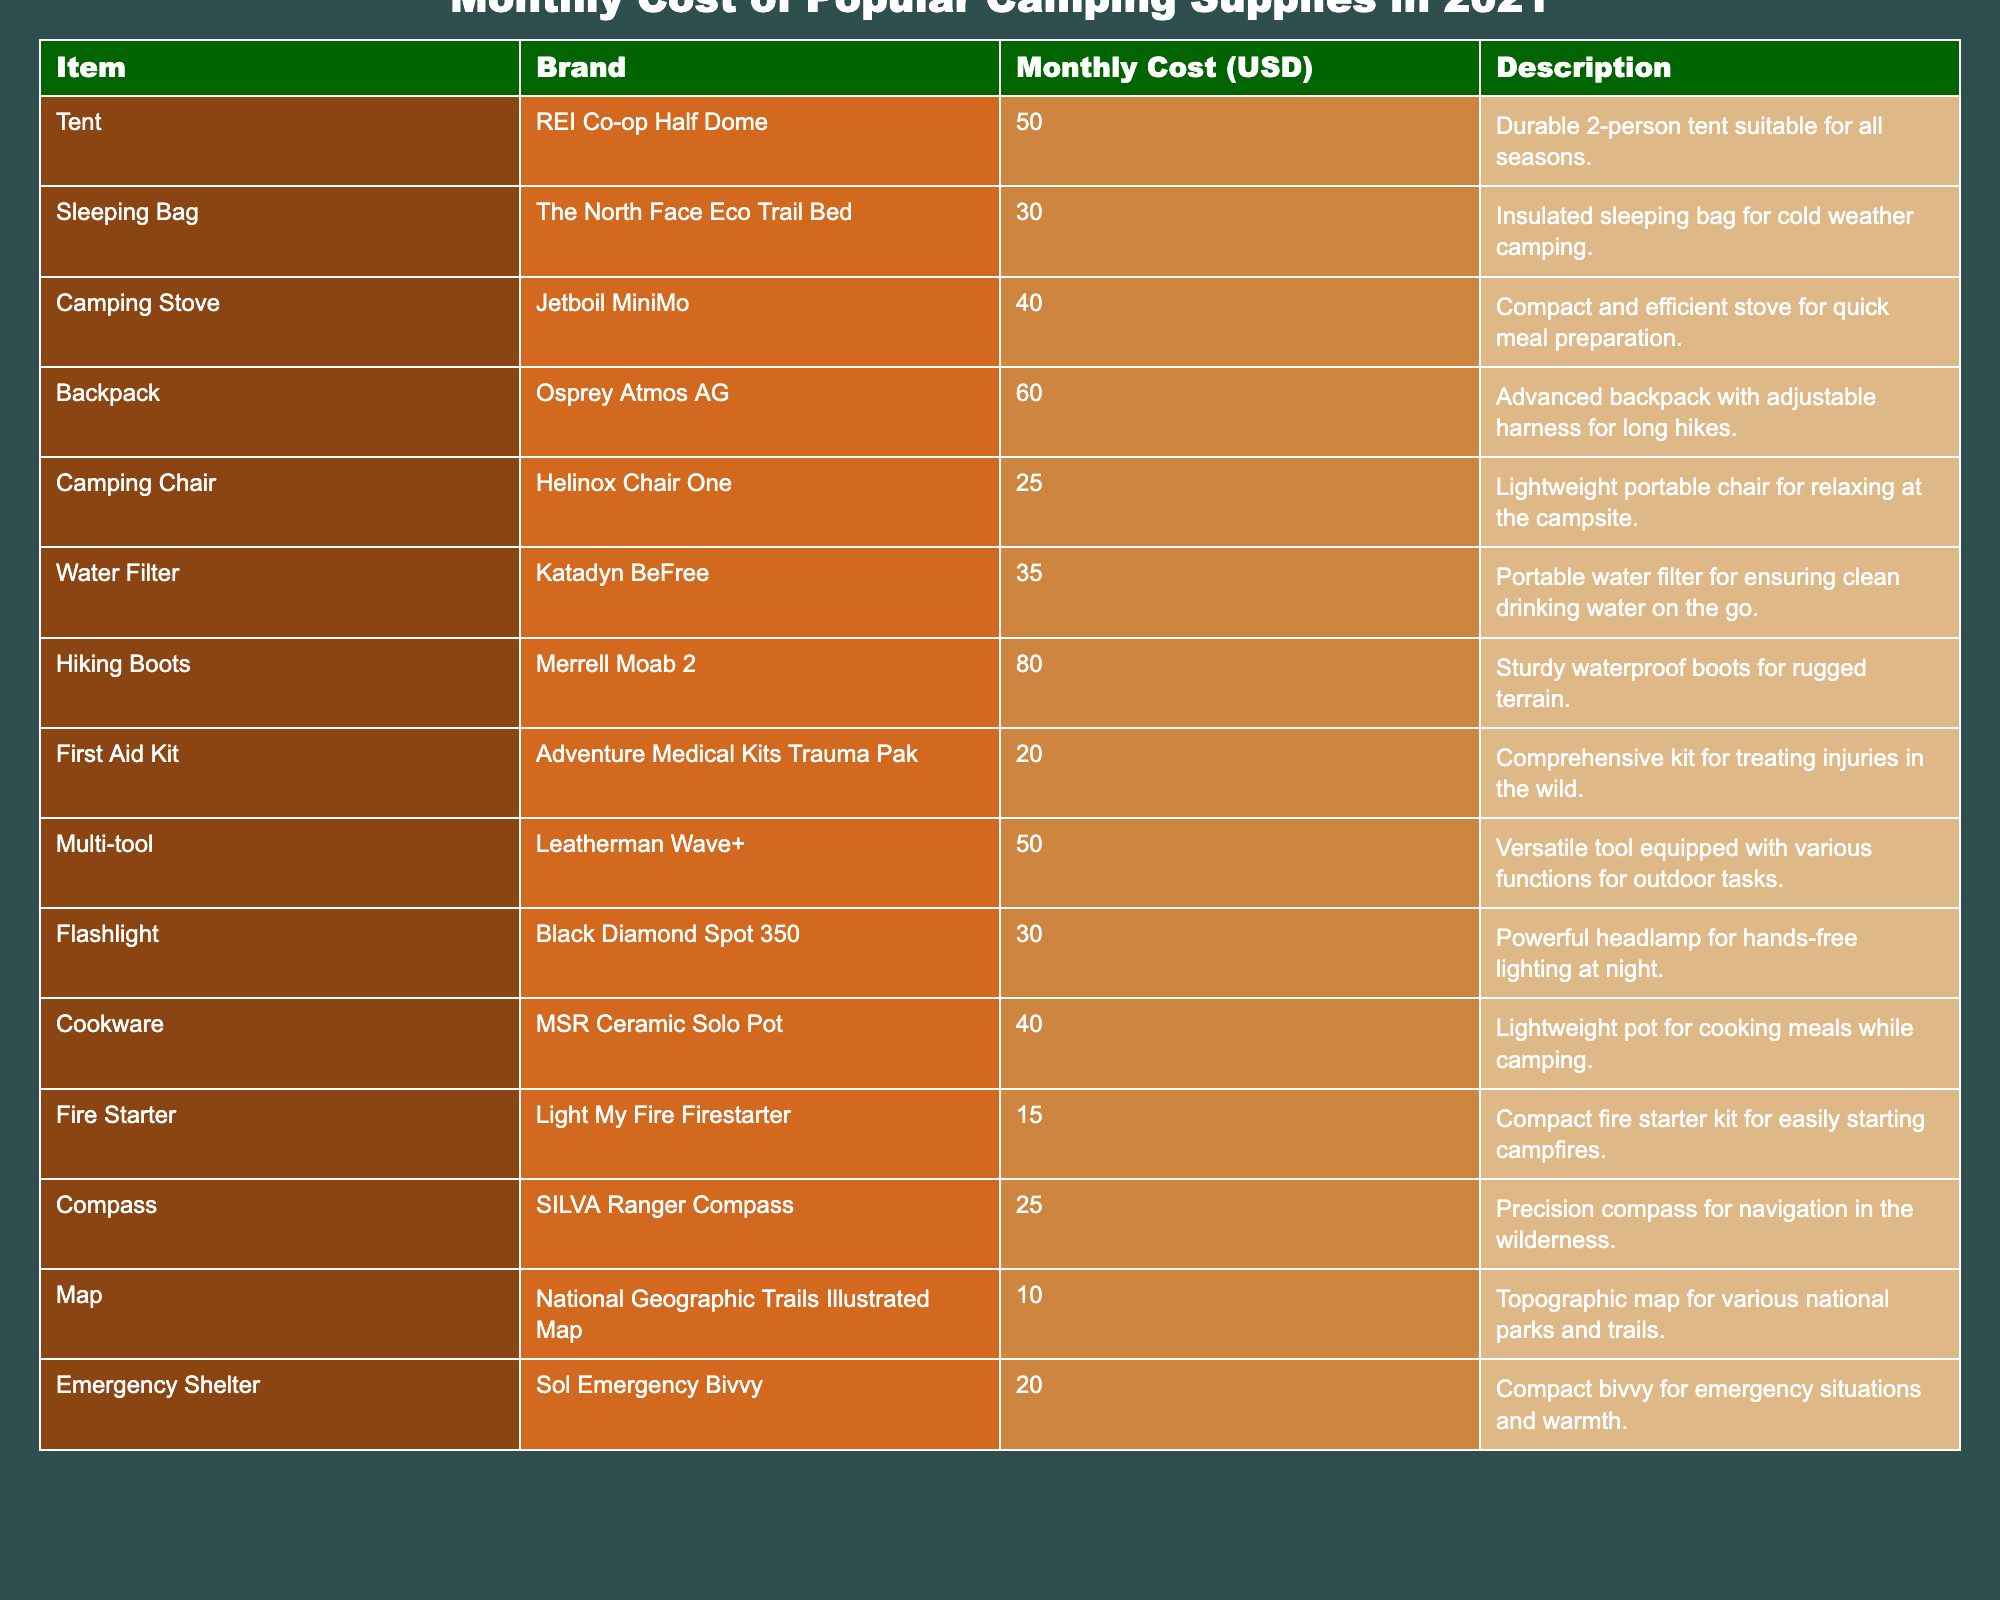What is the monthly cost of a camping stove? The table lists the monthly cost of a camping stove as 40 USD.
Answer: 40 USD What is the cheapest camping supply listed in the table? The cheapest camping supply is a map, which costs 10 USD.
Answer: Map - 10 USD What is the total monthly cost of buying a tent, sleeping bag, and backpack? The monthly costs of those items are 50 (tent) + 30 (sleeping bag) + 60 (backpack) = 140 USD.
Answer: 140 USD Does the table list any items that cost 20 USD? Yes, the First Aid Kit and Emergency Shelter each cost 20 USD.
Answer: Yes What is the monthly cost of the hiking boots compared to the camping chair? The hiking boots cost 80 USD while the camping chair costs 25 USD, so the hiking boots are more expensive by 55 USD.
Answer: 55 USD Which item has the second highest monthly cost? The item with the highest cost is the hiking boots at 80 USD, followed by the backpack at 60 USD, so the backpack is the second highest.
Answer: Backpack - 60 USD What is the average cost of all the camping supplies listed in the table? To find the average, first sum up all the costs: 50 + 30 + 40 + 60 + 25 + 35 + 80 + 20 + 50 + 30 + 40 + 15 + 25 + 10 + 20 =  475 USD. There are 15 items, so the average cost is 475 / 15 ≈ 31.67 USD.
Answer: Approximately 31.67 USD Are there more items that cost over 40 USD or under 40 USD? There are 7 items that cost over 40 USD (tent, backpack, hiking boots, multi-tool) and 8 items that cost under 40 USD. Thus, there are more items under 40 USD.
Answer: More items under 40 USD What is the total monthly cost of all the items categorized as "lighting supplies"? The only lighting supply listed is the flashlight, which costs 30 USD. Therefore, the total cost is 30 USD.
Answer: 30 USD Which item provides versatility through multiple functions? The multi-tool is specifically noted as a versatile tool equipped with various functions.
Answer: Multi-tool 